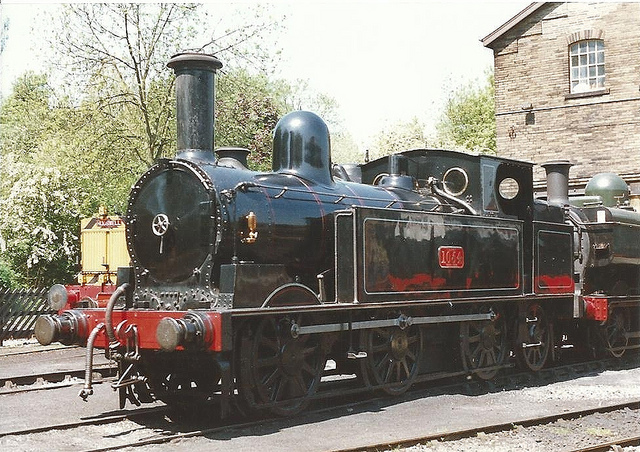Read all the text in this image. 1054 